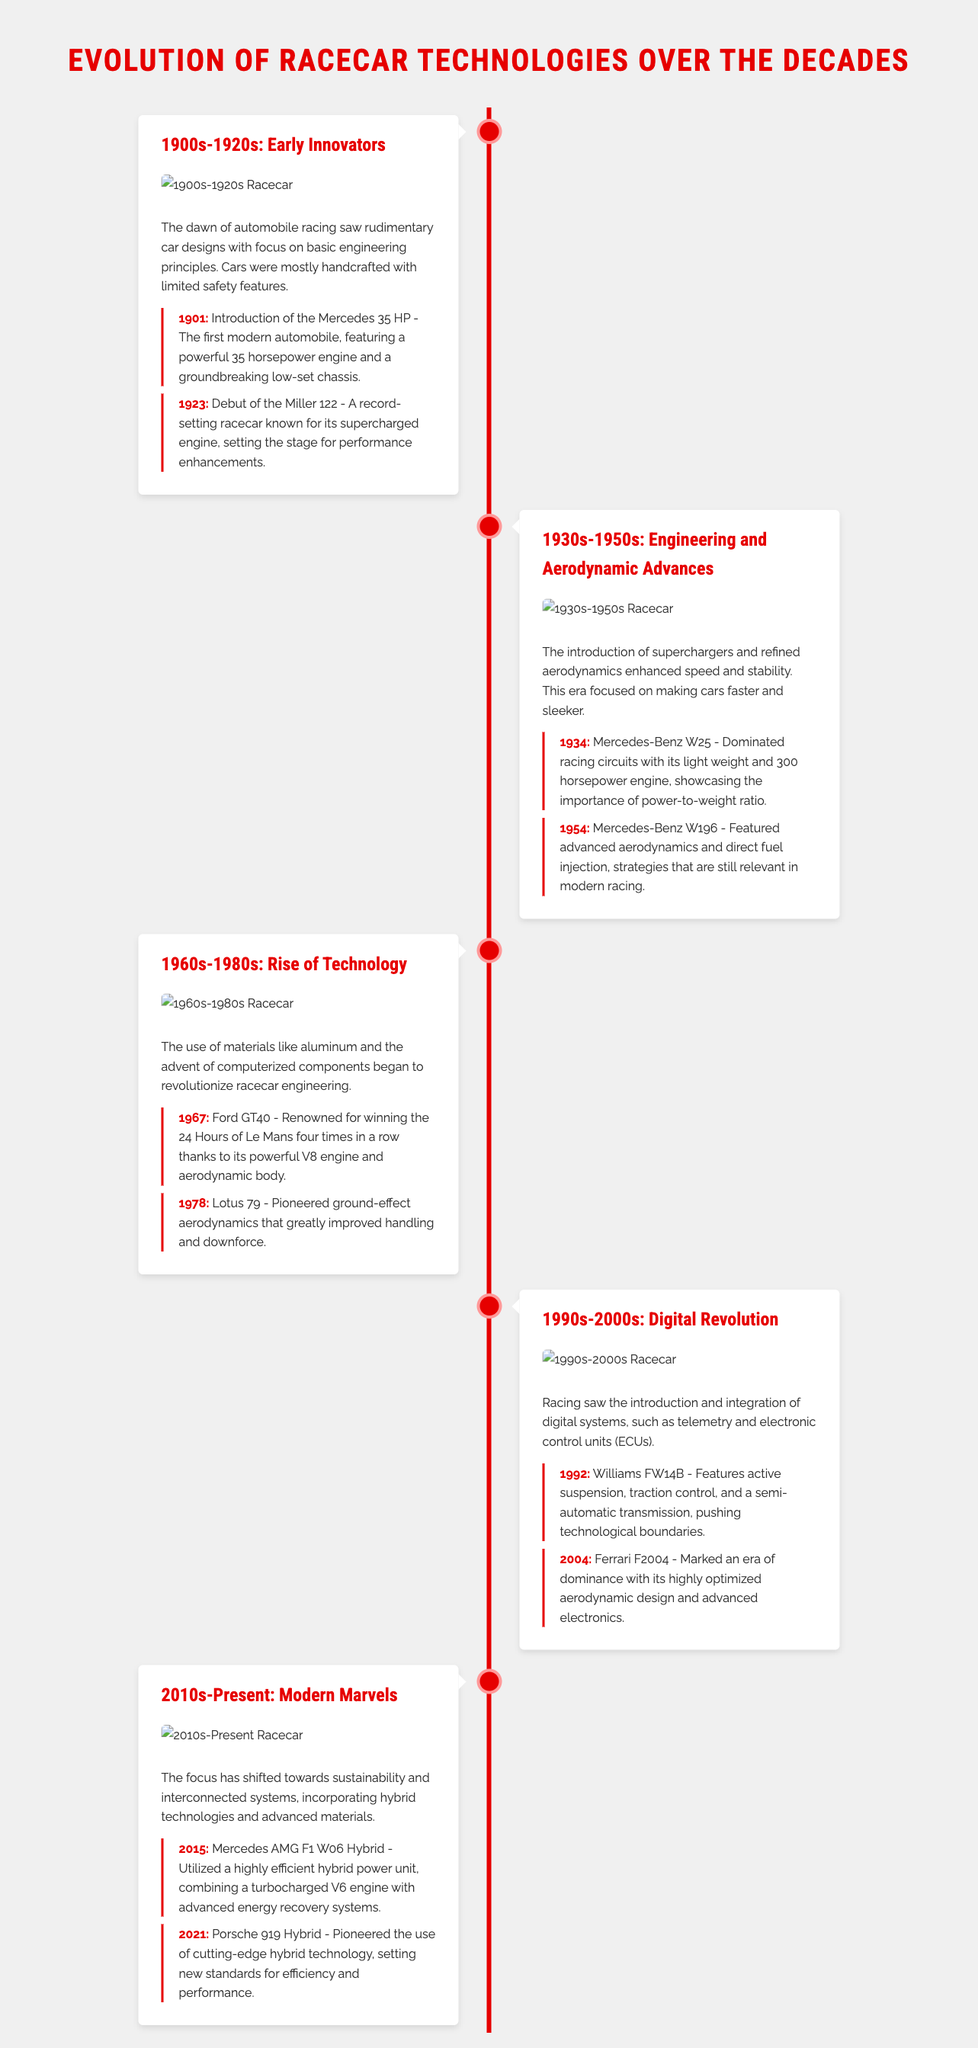what was the first modern automobile introduced? The document states that the first modern automobile was introduced in 1901, which was the Mercedes 35 HP.
Answer: Mercedes 35 HP which racecar debuted in 1923? The document mentions that the Miller 122 made its debut in 1923.
Answer: Miller 122 what significant feature did the Mercedes-Benz W196 have in 1954? The Mercedes-Benz W196 featured advanced aerodynamics and direct fuel injection.
Answer: advanced aerodynamics and direct fuel injection how many times did the Ford GT40 win the 24 Hours of Le Mans? According to the document, the Ford GT40 won the race four times in a row.
Answer: four times which racecar introduced active suspension in 1992? The Williams FW14B introduced active suspension in 1992.
Answer: Williams FW14B what year marked the debut of the Porsche 919 Hybrid? The document indicates that the Porsche 919 Hybrid debuted in 2021.
Answer: 2021 what key trend began in racecar technology from the 2010s? The document highlights that the focus has shifted towards sustainability and interconnected systems.
Answer: sustainability and interconnected systems which era saw the introduction of computerized components? The era encompassing the 1990s-2000s marked the introduction of computerized components.
Answer: 1990s-2000s who developed the Mercedes AMG F1 W06 Hybrid? The document credits Mercedes with the development of the AMG F1 W06 Hybrid.
Answer: Mercedes 